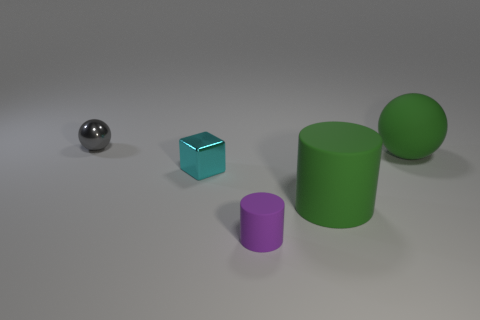There is a big rubber thing that is in front of the block; are there any balls that are left of it?
Ensure brevity in your answer.  Yes. How many gray metal things are behind the green cylinder that is in front of the small metal block?
Give a very brief answer. 1. There is a gray thing that is the same size as the cyan object; what is its material?
Your answer should be very brief. Metal. Do the big green object in front of the big green rubber sphere and the small purple thing have the same shape?
Your response must be concise. Yes. Are there more small rubber cylinders that are in front of the small cyan block than metallic blocks on the right side of the tiny purple cylinder?
Keep it short and to the point. Yes. How many other small gray balls are the same material as the small ball?
Your answer should be compact. 0. Is the size of the cyan metal object the same as the purple thing?
Your answer should be compact. Yes. The big matte sphere is what color?
Your response must be concise. Green. How many things are tiny cyan shiny objects or green things?
Provide a succinct answer. 3. Is there a yellow metallic object of the same shape as the small cyan metallic thing?
Give a very brief answer. No. 